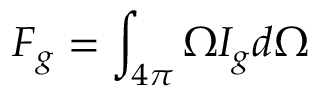<formula> <loc_0><loc_0><loc_500><loc_500>F _ { g } = \int _ { 4 \pi } \Omega I _ { g } d \Omega</formula> 